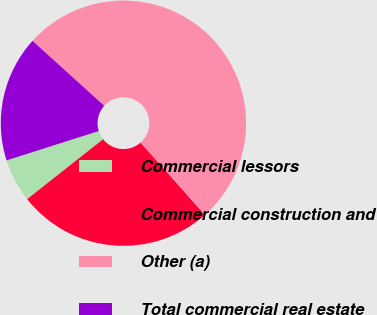<chart> <loc_0><loc_0><loc_500><loc_500><pie_chart><fcel>Commercial lessors<fcel>Commercial construction and<fcel>Other (a)<fcel>Total commercial real estate<nl><fcel>5.72%<fcel>25.93%<fcel>51.73%<fcel>16.62%<nl></chart> 